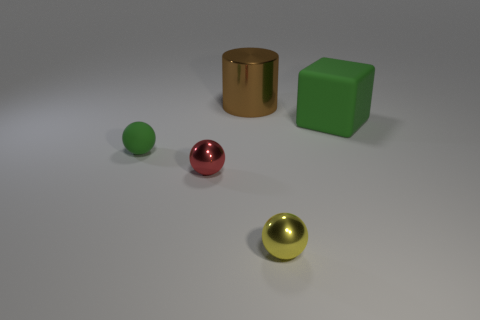What materials might the shiny objects in the image be made of? The objects in the image with a metallic sheen, such as the red sphere and golden yellow sphere, suggest they might be made of polished metals or materials with metallic paint finishes. 